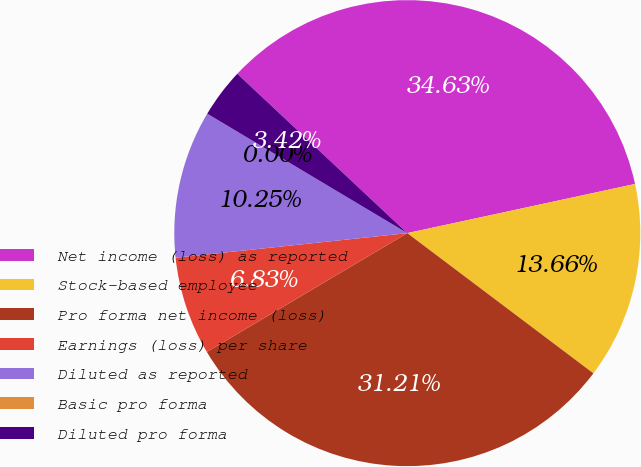Convert chart to OTSL. <chart><loc_0><loc_0><loc_500><loc_500><pie_chart><fcel>Net income (loss) as reported<fcel>Stock-based employee<fcel>Pro forma net income (loss)<fcel>Earnings (loss) per share<fcel>Diluted as reported<fcel>Basic pro forma<fcel>Diluted pro forma<nl><fcel>34.63%<fcel>13.66%<fcel>31.21%<fcel>6.83%<fcel>10.25%<fcel>0.0%<fcel>3.42%<nl></chart> 